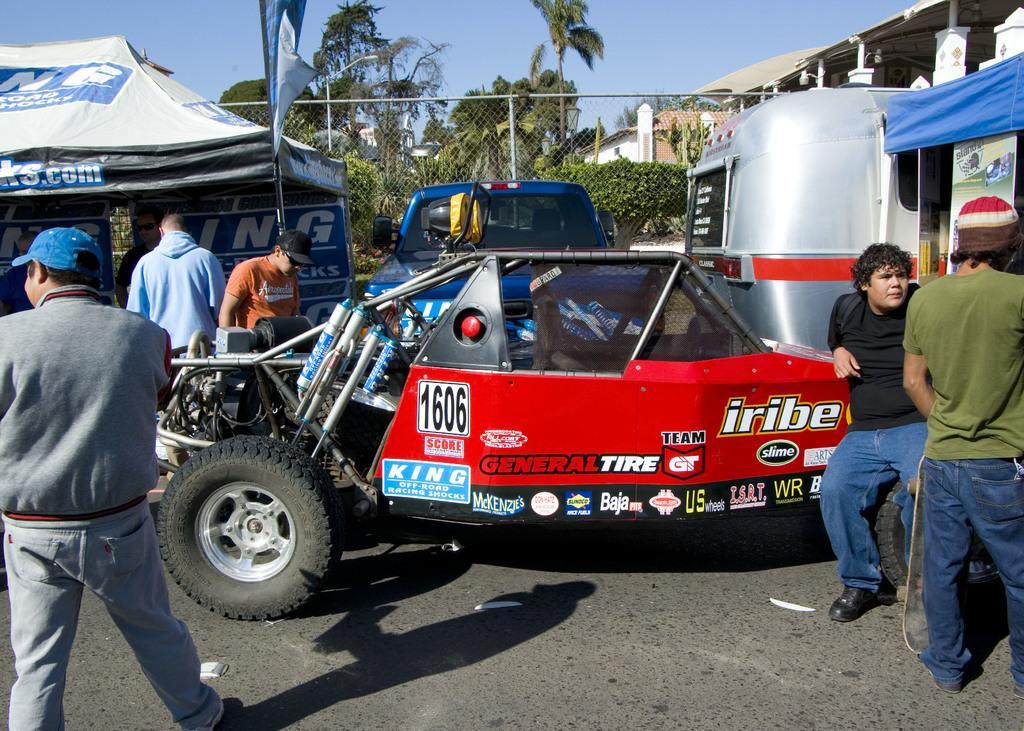Please provide a concise description of this image. In this image we can see vehicles in the foreground. Behind the vehicles we can see a fencing, few plants and trees. On the left side, we can see a tent and few people. On the right side, we can see a tent, building and two persons. 